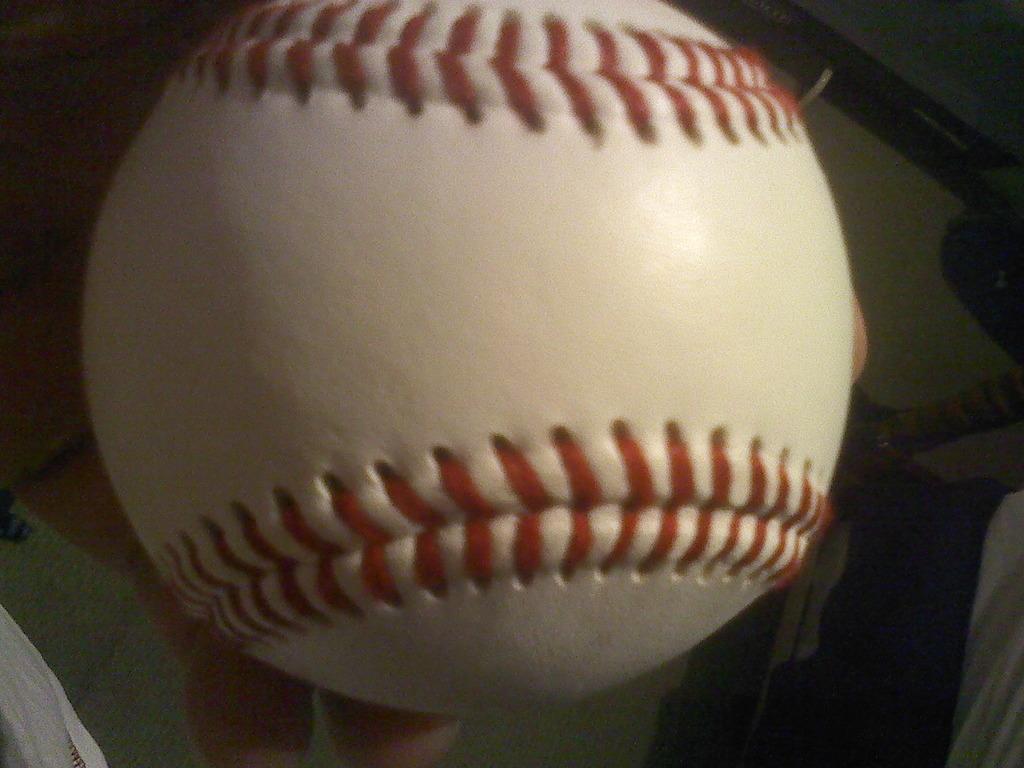How would you summarize this image in a sentence or two? In this image I can see a human hand holding a ball which is white and red in color. I can see few other objects in the background. 